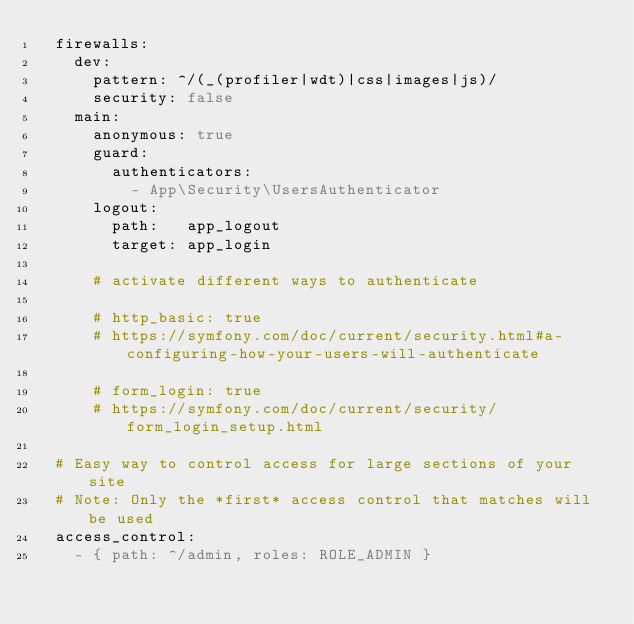Convert code to text. <code><loc_0><loc_0><loc_500><loc_500><_YAML_>  firewalls:
    dev:
      pattern: ^/(_(profiler|wdt)|css|images|js)/
      security: false
    main:
      anonymous: true
      guard:
        authenticators:
          - App\Security\UsersAuthenticator
      logout:
        path:   app_logout
        target: app_login

      # activate different ways to authenticate

      # http_basic: true
      # https://symfony.com/doc/current/security.html#a-configuring-how-your-users-will-authenticate

      # form_login: true
      # https://symfony.com/doc/current/security/form_login_setup.html

  # Easy way to control access for large sections of your site
  # Note: Only the *first* access control that matches will be used
  access_control:
    - { path: ^/admin, roles: ROLE_ADMIN }</code> 